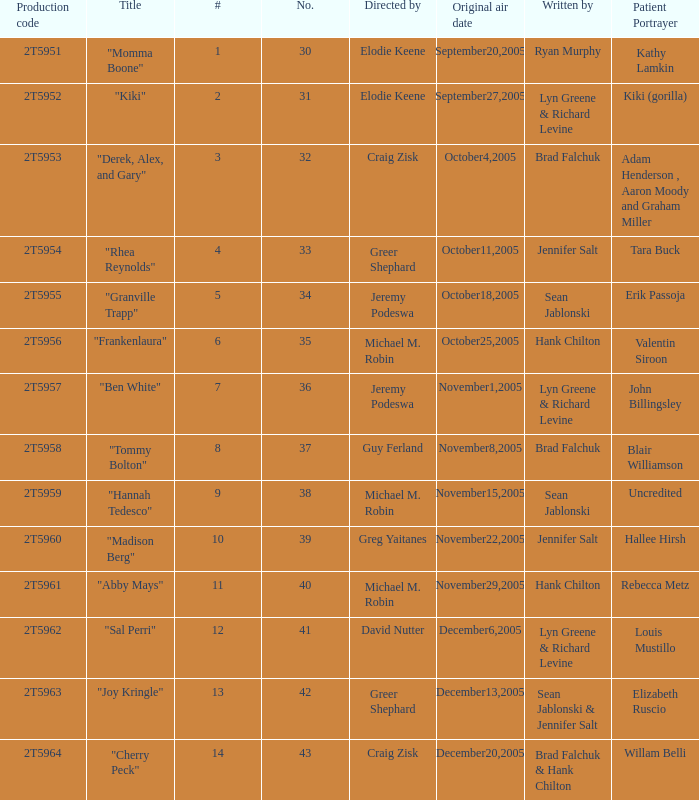What is the total number of patient portayers for the episode directed by Craig Zisk and written by Brad Falchuk? 1.0. 